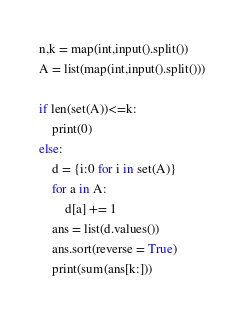<code> <loc_0><loc_0><loc_500><loc_500><_Python_>n,k = map(int,input().split())
A = list(map(int,input().split()))

if len(set(A))<=k:
    print(0)
else:
    d = {i:0 for i in set(A)}
    for a in A:
        d[a] += 1
    ans = list(d.values())
    ans.sort(reverse = True)
    print(sum(ans[k:]))</code> 